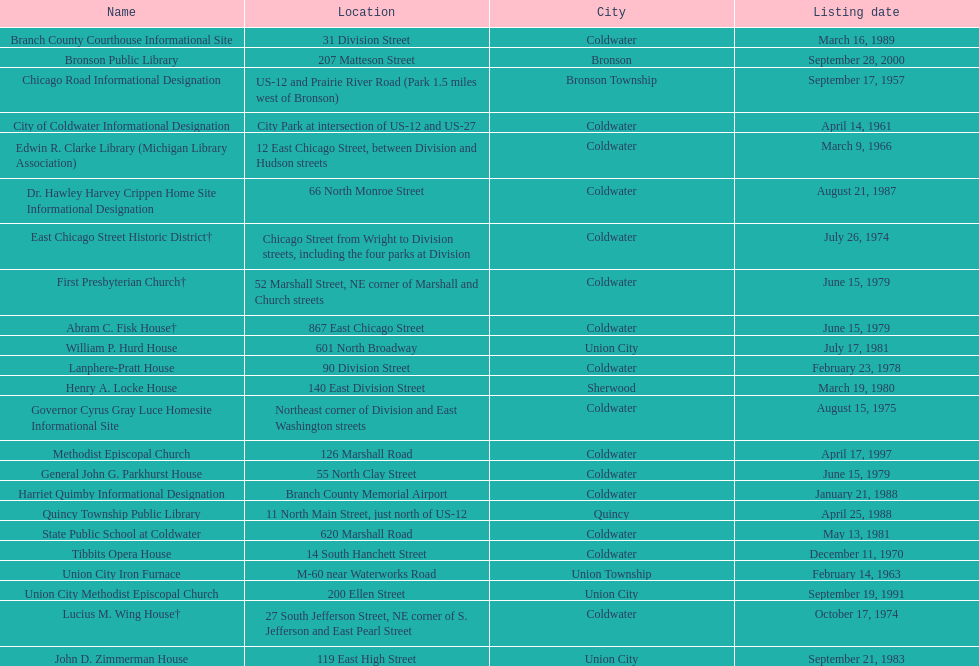What is the name with the only listing date on april 14, 1961 City of Coldwater. Could you parse the entire table as a dict? {'header': ['Name', 'Location', 'City', 'Listing date'], 'rows': [['Branch County Courthouse Informational Site', '31 Division Street', 'Coldwater', 'March 16, 1989'], ['Bronson Public Library', '207 Matteson Street', 'Bronson', 'September 28, 2000'], ['Chicago Road Informational Designation', 'US-12 and Prairie River Road (Park 1.5 miles west of Bronson)', 'Bronson Township', 'September 17, 1957'], ['City of Coldwater Informational Designation', 'City Park at intersection of US-12 and US-27', 'Coldwater', 'April 14, 1961'], ['Edwin R. Clarke Library (Michigan Library Association)', '12 East Chicago Street, between Division and Hudson streets', 'Coldwater', 'March 9, 1966'], ['Dr. Hawley Harvey Crippen Home Site Informational Designation', '66 North Monroe Street', 'Coldwater', 'August 21, 1987'], ['East Chicago Street Historic District†', 'Chicago Street from Wright to Division streets, including the four parks at Division', 'Coldwater', 'July 26, 1974'], ['First Presbyterian Church†', '52 Marshall Street, NE corner of Marshall and Church streets', 'Coldwater', 'June 15, 1979'], ['Abram C. Fisk House†', '867 East Chicago Street', 'Coldwater', 'June 15, 1979'], ['William P. Hurd House', '601 North Broadway', 'Union City', 'July 17, 1981'], ['Lanphere-Pratt House', '90 Division Street', 'Coldwater', 'February 23, 1978'], ['Henry A. Locke House', '140 East Division Street', 'Sherwood', 'March 19, 1980'], ['Governor Cyrus Gray Luce Homesite Informational Site', 'Northeast corner of Division and East Washington streets', 'Coldwater', 'August 15, 1975'], ['Methodist Episcopal Church', '126 Marshall Road', 'Coldwater', 'April 17, 1997'], ['General John G. Parkhurst House', '55 North Clay Street', 'Coldwater', 'June 15, 1979'], ['Harriet Quimby Informational Designation', 'Branch County Memorial Airport', 'Coldwater', 'January 21, 1988'], ['Quincy Township Public Library', '11 North Main Street, just north of US-12', 'Quincy', 'April 25, 1988'], ['State Public School at Coldwater', '620 Marshall Road', 'Coldwater', 'May 13, 1981'], ['Tibbits Opera House', '14 South Hanchett Street', 'Coldwater', 'December 11, 1970'], ['Union City Iron Furnace', 'M-60 near Waterworks Road', 'Union Township', 'February 14, 1963'], ['Union City Methodist Episcopal Church', '200 Ellen Street', 'Union City', 'September 19, 1991'], ['Lucius M. Wing House†', '27 South Jefferson Street, NE corner of S. Jefferson and East Pearl Street', 'Coldwater', 'October 17, 1974'], ['John D. Zimmerman House', '119 East High Street', 'Union City', 'September 21, 1983']]} 